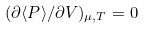Convert formula to latex. <formula><loc_0><loc_0><loc_500><loc_500>( \partial \langle P \rangle / \partial V ) _ { \mu , T } = 0</formula> 